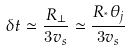Convert formula to latex. <formula><loc_0><loc_0><loc_500><loc_500>\delta t \simeq \frac { R _ { \perp } } { 3 v _ { s } } \simeq \frac { R _ { ^ { * } } \theta _ { j } } { 3 v _ { s } }</formula> 